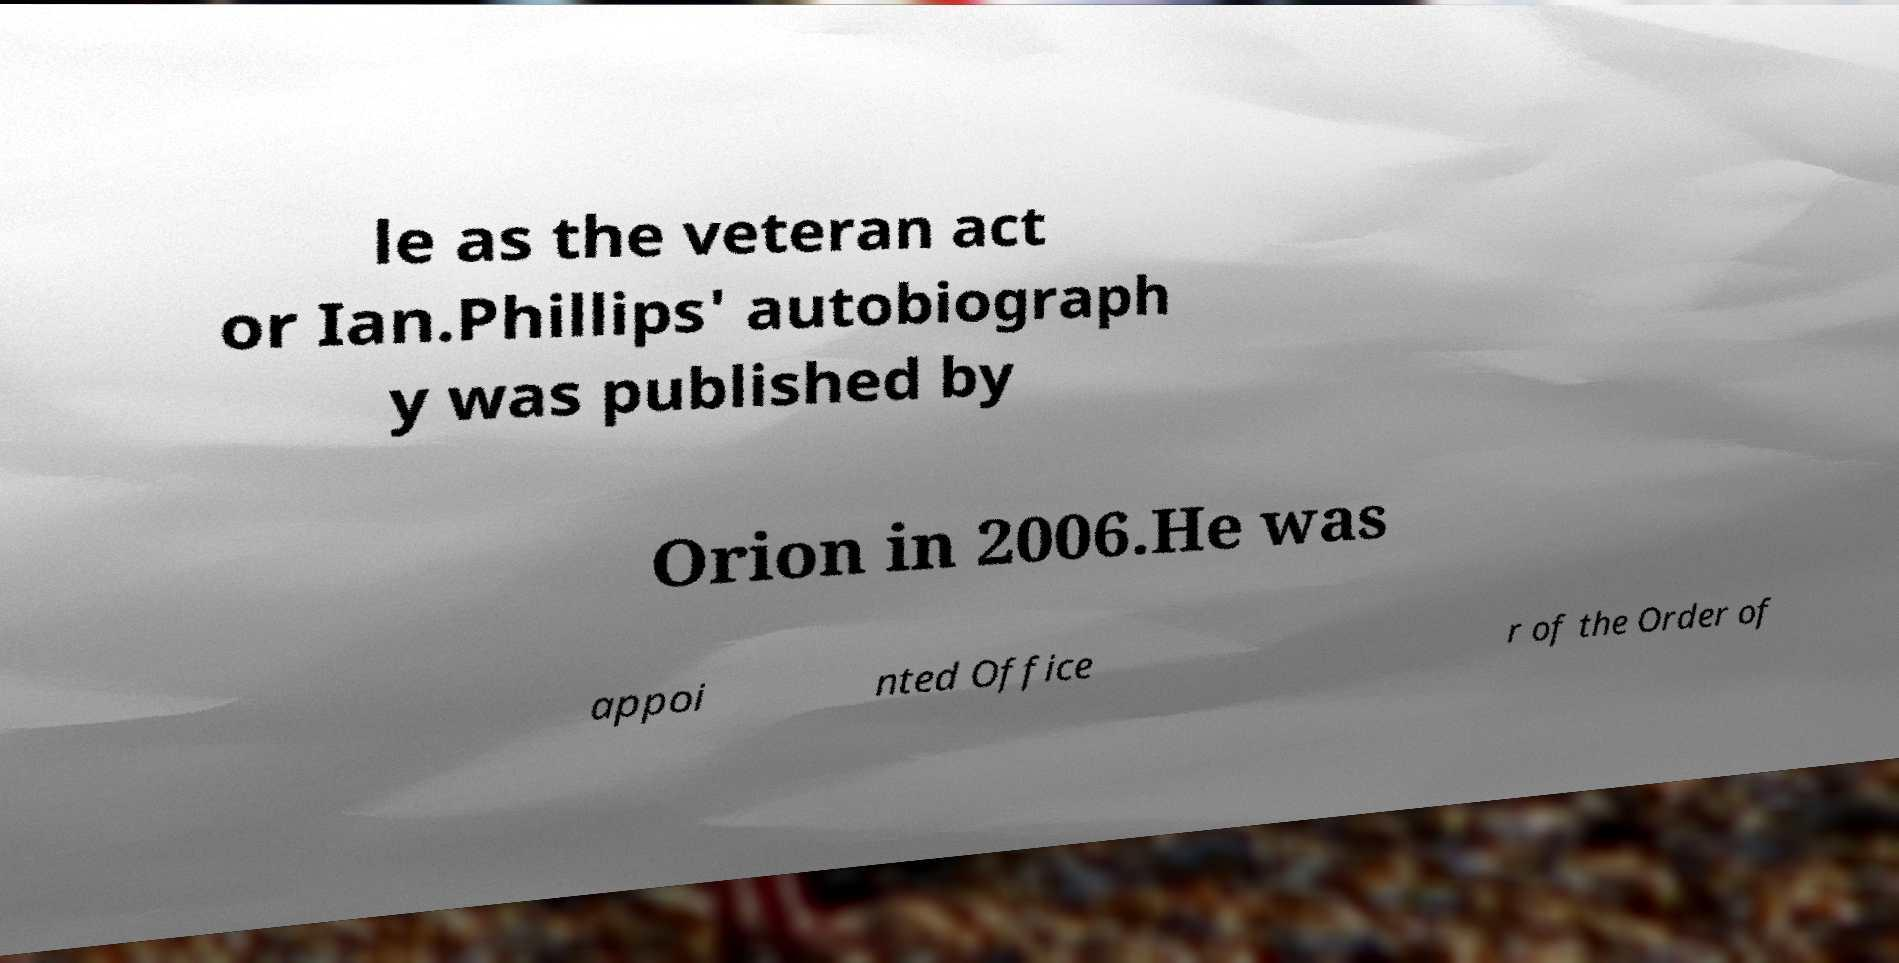For documentation purposes, I need the text within this image transcribed. Could you provide that? le as the veteran act or Ian.Phillips' autobiograph y was published by Orion in 2006.He was appoi nted Office r of the Order of 